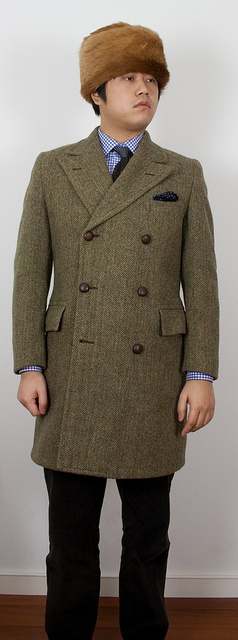Describe the objects in this image and their specific colors. I can see people in lightgray, gray, and black tones and tie in lightgray, black, gray, and darkblue tones in this image. 